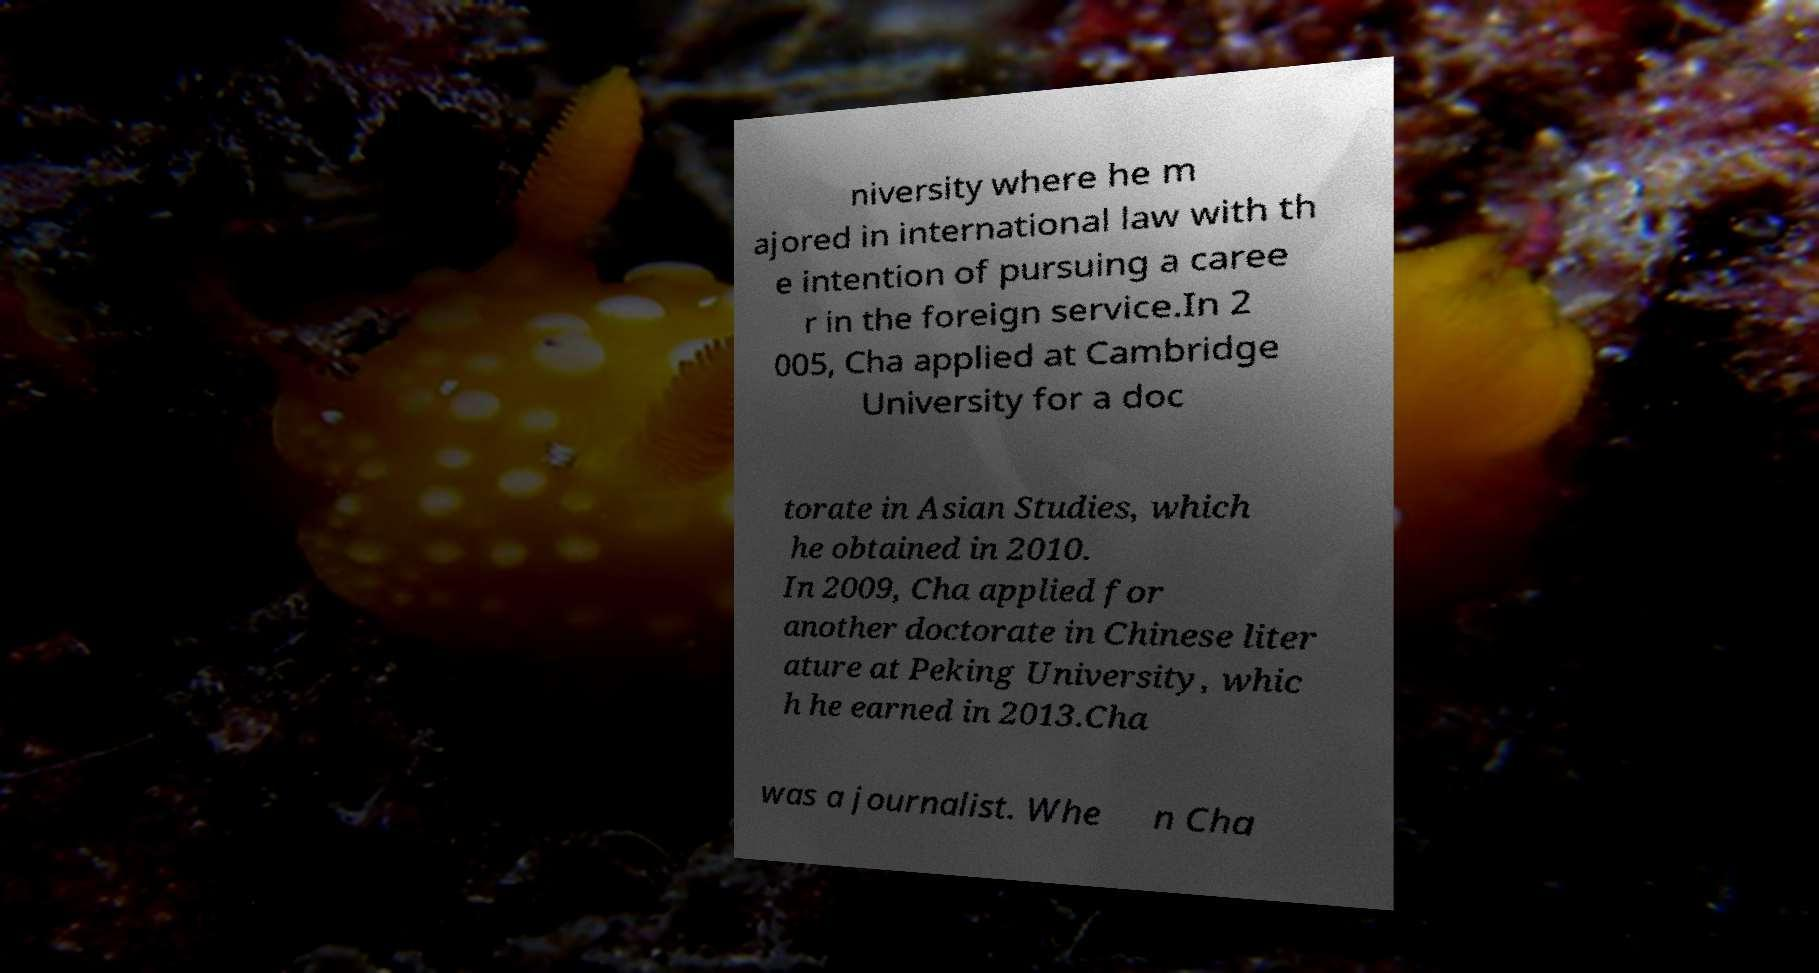Can you accurately transcribe the text from the provided image for me? niversity where he m ajored in international law with th e intention of pursuing a caree r in the foreign service.In 2 005, Cha applied at Cambridge University for a doc torate in Asian Studies, which he obtained in 2010. In 2009, Cha applied for another doctorate in Chinese liter ature at Peking University, whic h he earned in 2013.Cha was a journalist. Whe n Cha 